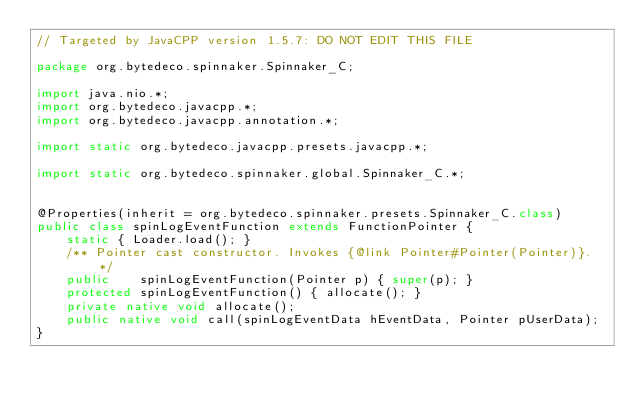Convert code to text. <code><loc_0><loc_0><loc_500><loc_500><_Java_>// Targeted by JavaCPP version 1.5.7: DO NOT EDIT THIS FILE

package org.bytedeco.spinnaker.Spinnaker_C;

import java.nio.*;
import org.bytedeco.javacpp.*;
import org.bytedeco.javacpp.annotation.*;

import static org.bytedeco.javacpp.presets.javacpp.*;

import static org.bytedeco.spinnaker.global.Spinnaker_C.*;


@Properties(inherit = org.bytedeco.spinnaker.presets.Spinnaker_C.class)
public class spinLogEventFunction extends FunctionPointer {
    static { Loader.load(); }
    /** Pointer cast constructor. Invokes {@link Pointer#Pointer(Pointer)}. */
    public    spinLogEventFunction(Pointer p) { super(p); }
    protected spinLogEventFunction() { allocate(); }
    private native void allocate();
    public native void call(spinLogEventData hEventData, Pointer pUserData);
}
</code> 